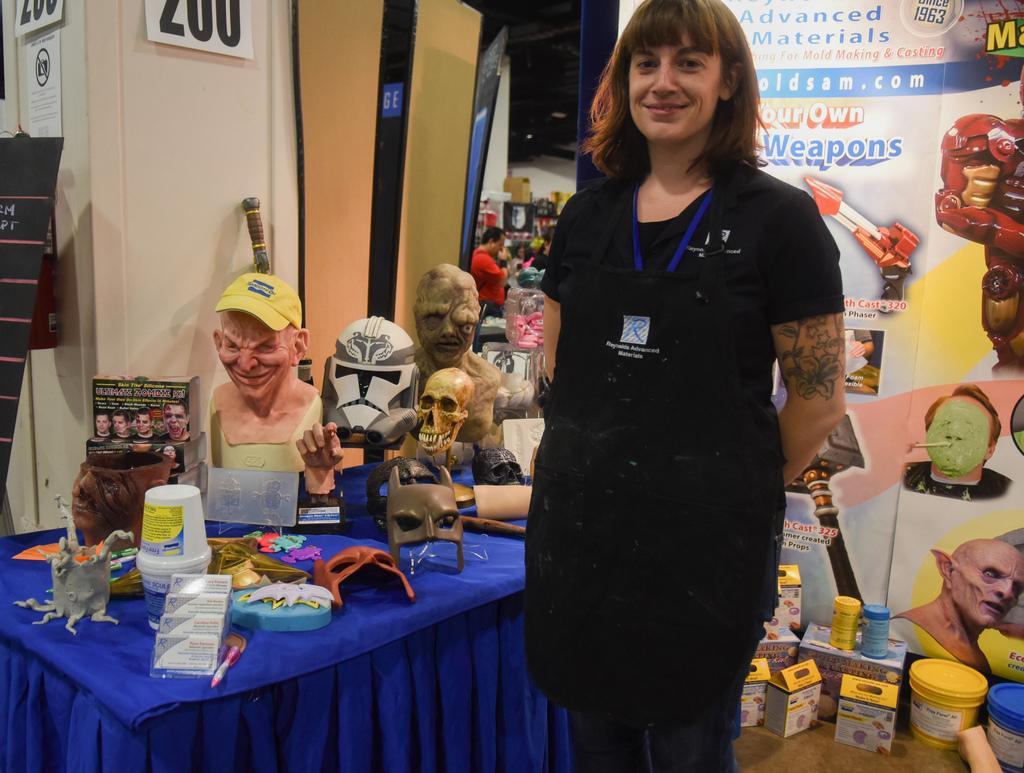How would you summarize this image in a sentence or two? In the middle of the image a woman is standing and smiling. Behind her there is a table, on the table there are some masks and there are some products and there is a banner. 